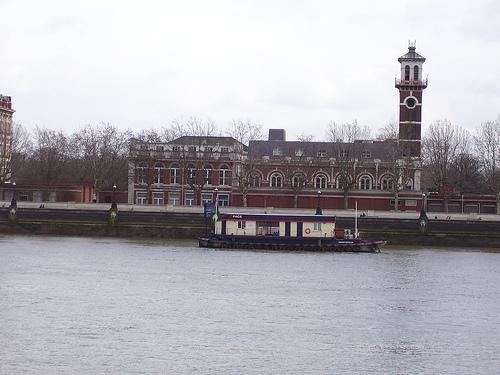Question: what color is the building behind the boat?
Choices:
A. Brown.
B. Red.
C. Black.
D. White.
Answer with the letter. Answer: B Question: how many boats do you see?
Choices:
A. One.
B. Two.
C. Three.
D. None.
Answer with the letter. Answer: A Question: what are in front of the building?
Choices:
A. Cars.
B. Buses.
C. Flowers.
D. Trees.
Answer with the letter. Answer: D Question: where is the red building?
Choices:
A. In front of the boat.
B. To the right of the boat.
C. To the left of the boat.
D. Behind the boat.
Answer with the letter. Answer: D Question: what is on the water?
Choices:
A. A leaf.
B. A boat.
C. A dolphin.
D. A ship.
Answer with the letter. Answer: B 